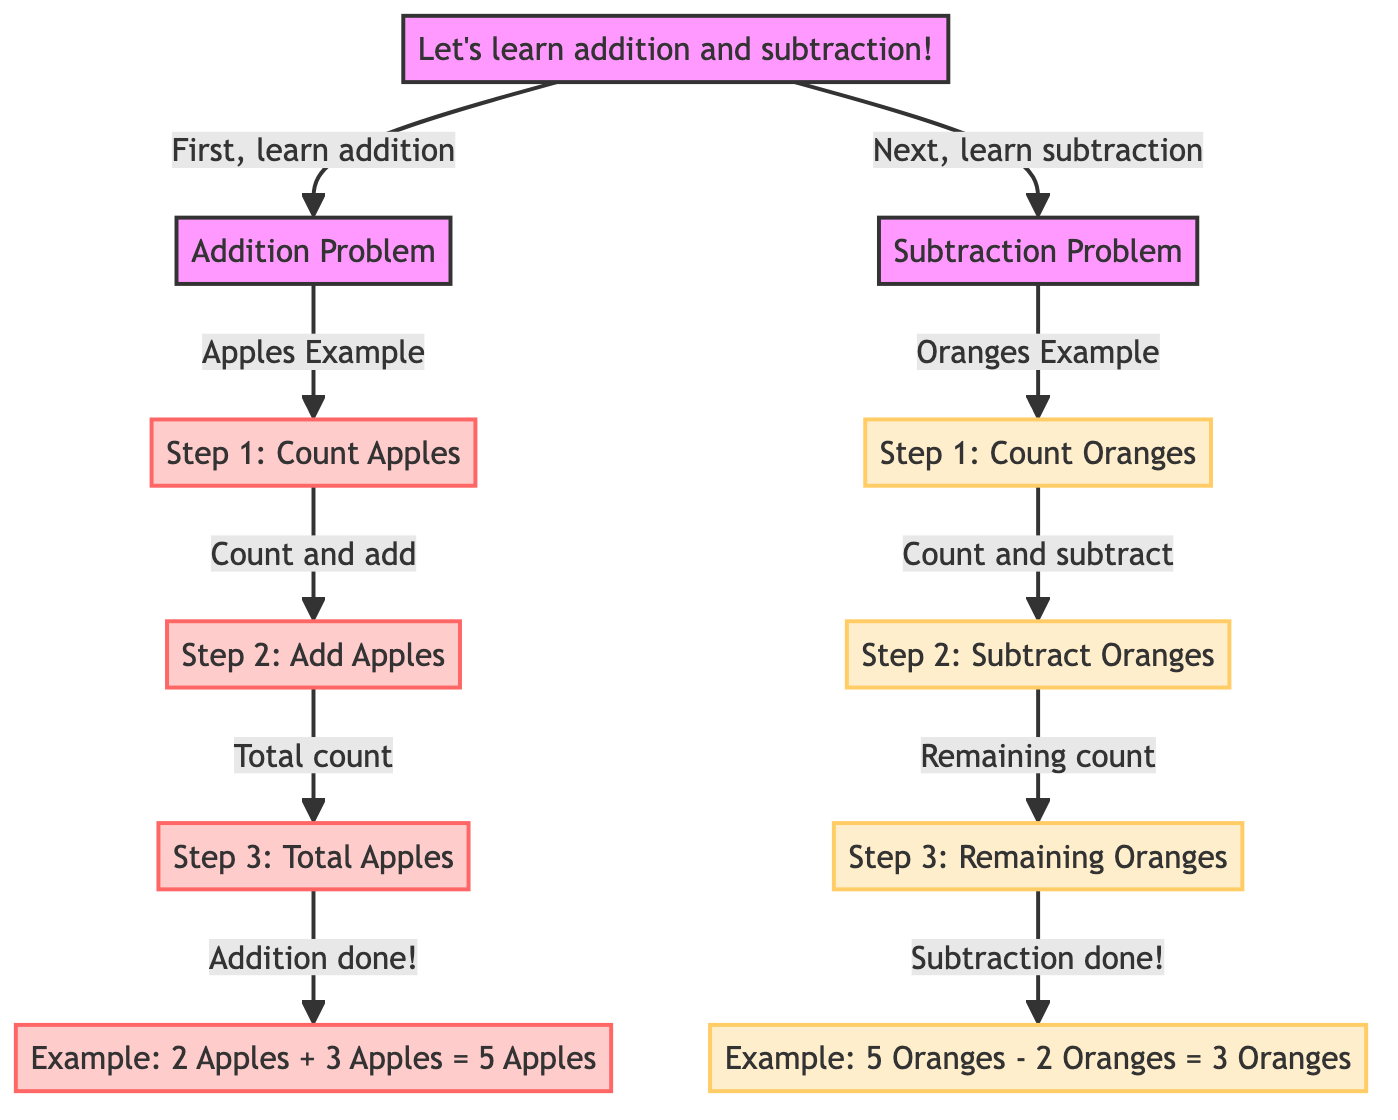What is the first problem type presented in the diagram? The diagram starts with "Addition Problem" after the initial instruction "Let's learn addition and subtraction!", indicating that addition is the first problem type introduced.
Answer: Addition Problem How many steps are in the addition section? The addition section includes four steps: Step 1: Count Apples, Step 2: Add Apples, Step 3: Total Apples, and an Example. Therefore, there are four steps in total.
Answer: 4 What is the total number of nodes in the subtraction section? The subtraction section has four nodes: Step 1: Count Oranges, Step 2: Subtract Oranges, Step 3: Remaining Oranges, and an Example. So, there are four nodes in total for subtraction.
Answer: 4 What is the final output of the addition example? The addition example states "2 Apples + 3 Apples = 5 Apples", indicating that the final output or total after the addition is five apples.
Answer: 5 Apples What is subtracted in the subtraction example? The subtraction example mentions "5 Oranges - 2 Oranges", thus indicating that two oranges are subtracted from five oranges.
Answer: 2 Oranges What color is used for the addition steps in the diagram? The addition steps are highlighted in the color represented as apple, which is a light pink shade (ffcccc).
Answer: apple What comes after counting oranges in the subtraction section? Following "Step 1: Count Oranges," the next step is "Step 2: Subtract Oranges," indicating that subtraction occurs immediately after counting.
Answer: Step 2: Subtract Oranges How many total sections are there that explain the problems in the diagram? There are two main sections in the diagram: one for addition and one for subtraction, so the total number of sections is two.
Answer: 2 